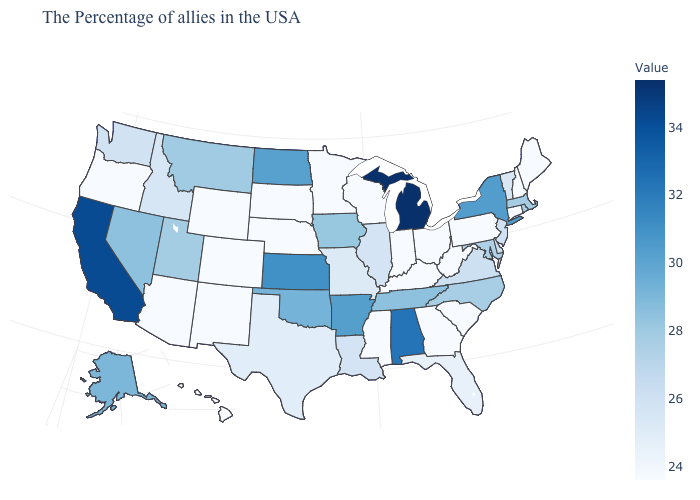Is the legend a continuous bar?
Answer briefly. Yes. Does Michigan have the highest value in the MidWest?
Give a very brief answer. Yes. Among the states that border Connecticut , which have the highest value?
Keep it brief. New York. Which states have the lowest value in the Northeast?
Concise answer only. Maine, New Hampshire, Connecticut, Pennsylvania. Among the states that border South Carolina , which have the lowest value?
Answer briefly. Georgia. Does South Carolina have the lowest value in the South?
Give a very brief answer. Yes. Does the map have missing data?
Concise answer only. No. 